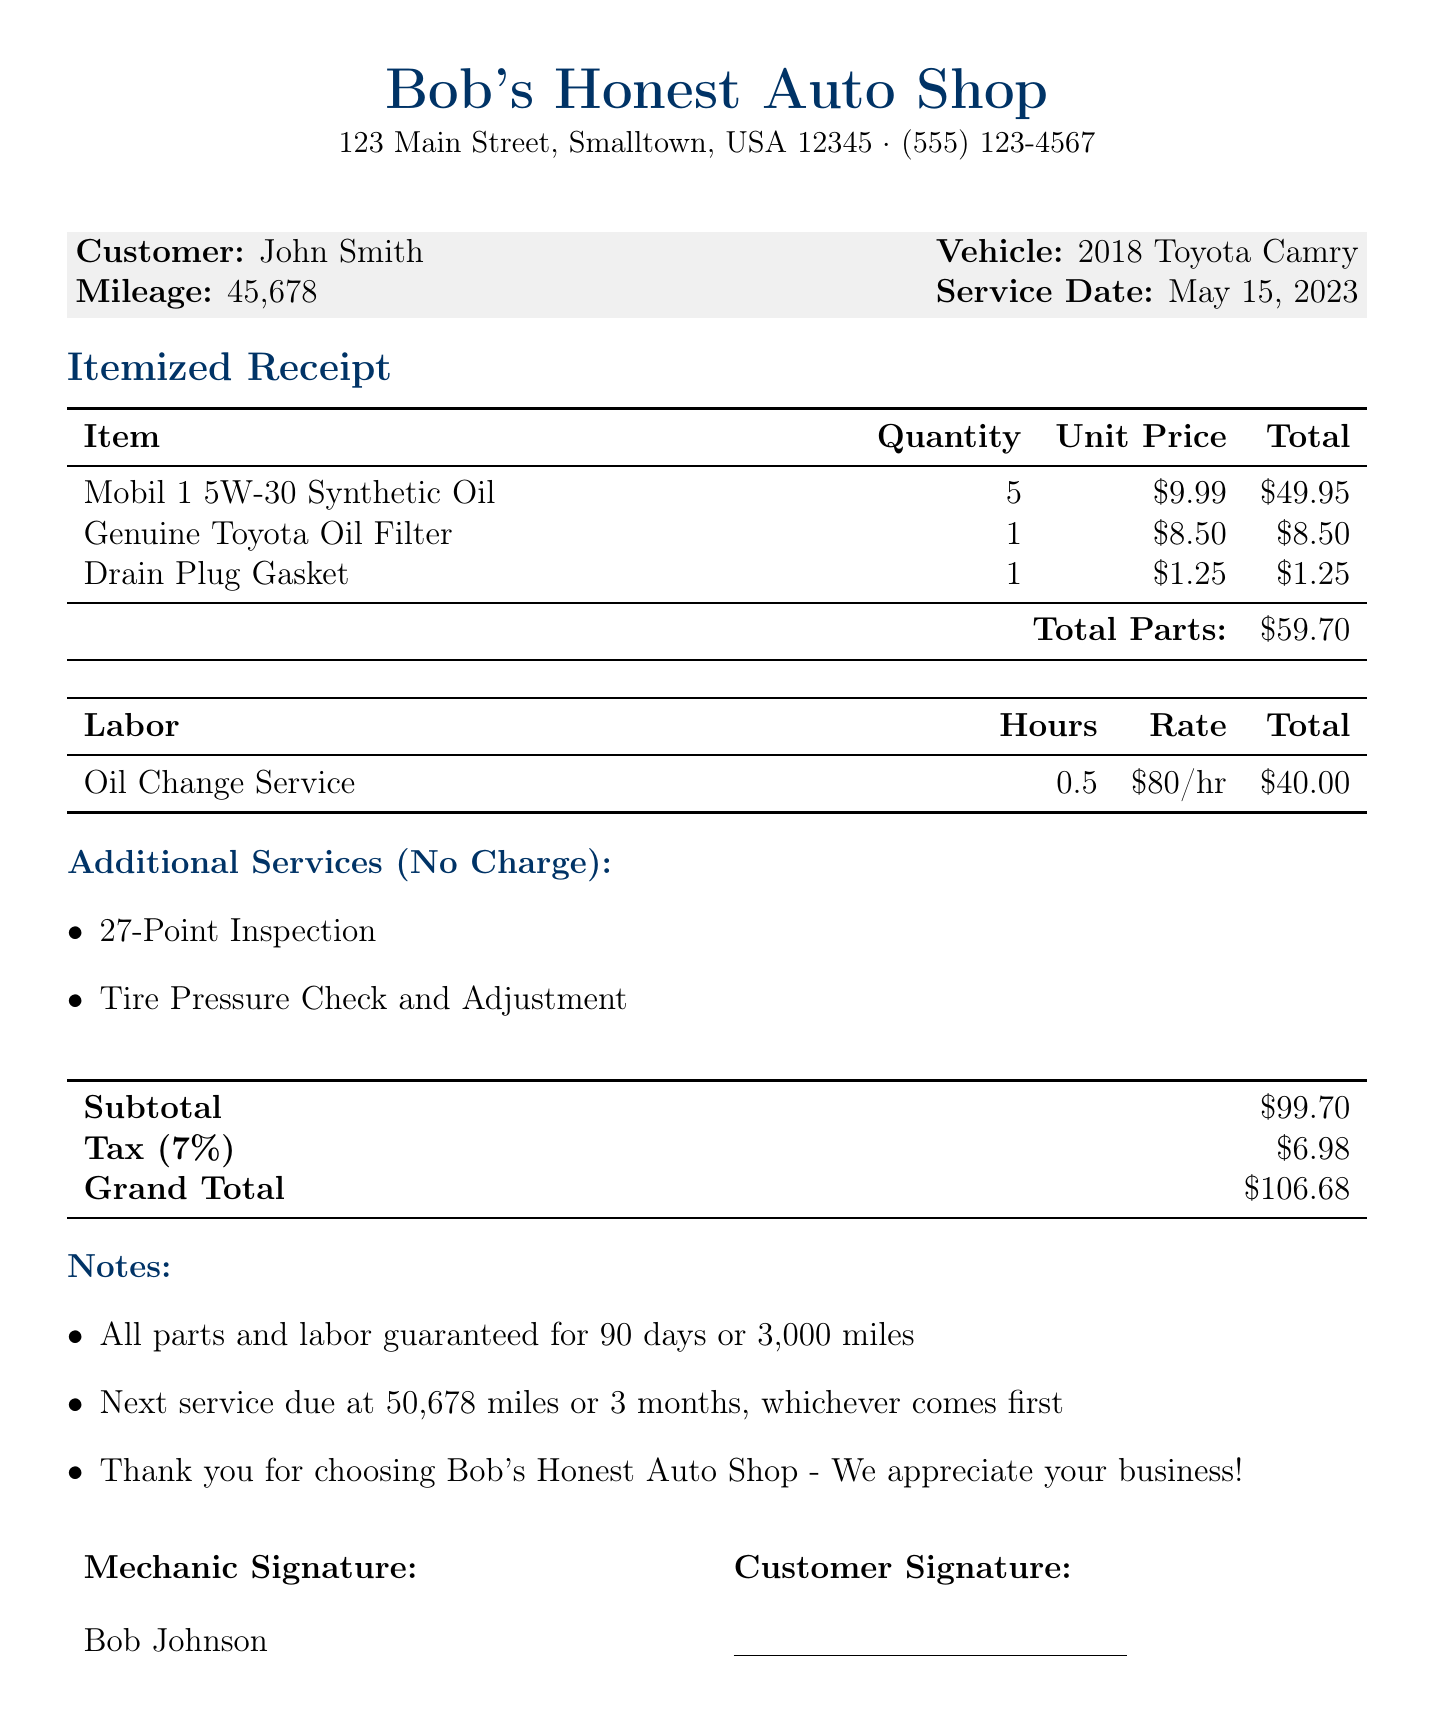What is the business name? The business name is listed at the top of the document.
Answer: Bob's Honest Auto Shop Who is the customer? The customer information is provided in a section of the document.
Answer: John Smith What is the vehicle type? The vehicle information is included next to the customer name.
Answer: 2018 Toyota Camry What was the service date? The service date is specified in the customer information section.
Answer: May 15, 2023 How much did the oil cost? The cost of the oil is listed in the itemized receipt section.
Answer: 49.95 What is the total labor cost? The total labor cost is detailed in the labor section of the document.
Answer: 40 What is the subtotal amount? The subtotal is provided at the bottom of the itemized receipt.
Answer: 99.70 What services were provided at no charge? The additional services section lists services with zero charge.
Answer: 27-Point Inspection, Tire Pressure Check and Adjustment What is the grand total for the service? The grand total is clearly specified in the summary table at the end of the document.
Answer: 106.68 